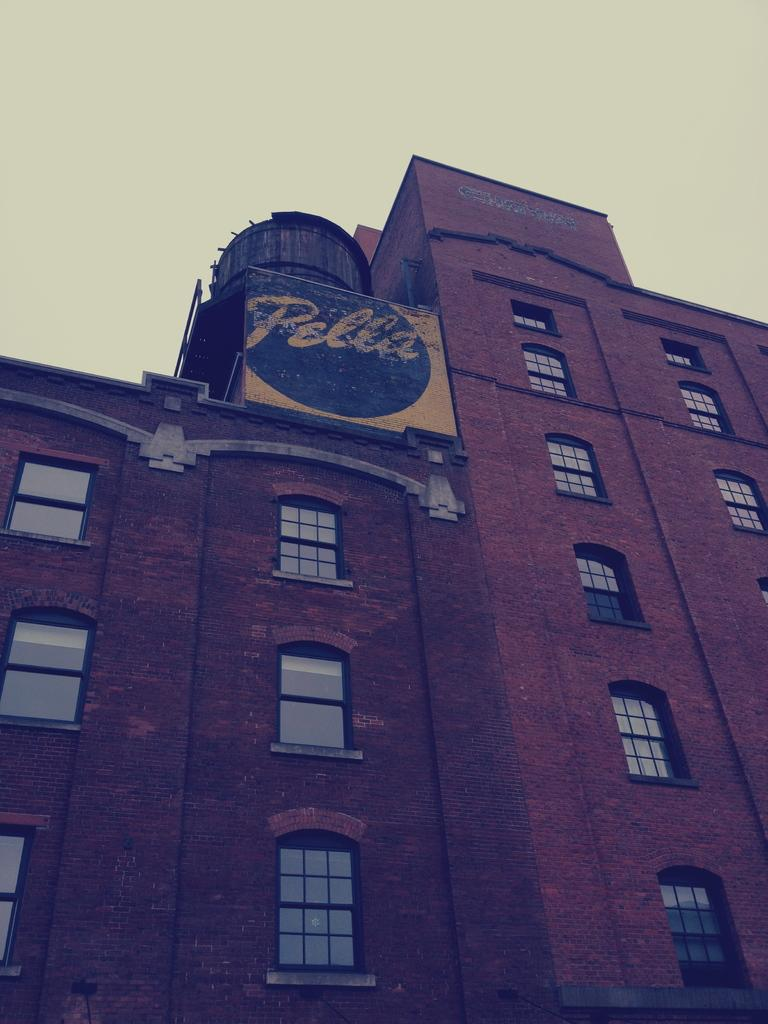What is the color of the building in the image? The building in the image is brown. What feature can be seen on the building? The building has windows. What can be seen in the background of the image? The sky is visible in the background of the image. What is the taste of the building in the image? Buildings do not have a taste, as they are inanimate objects made of materials like brick, concrete, or wood. 